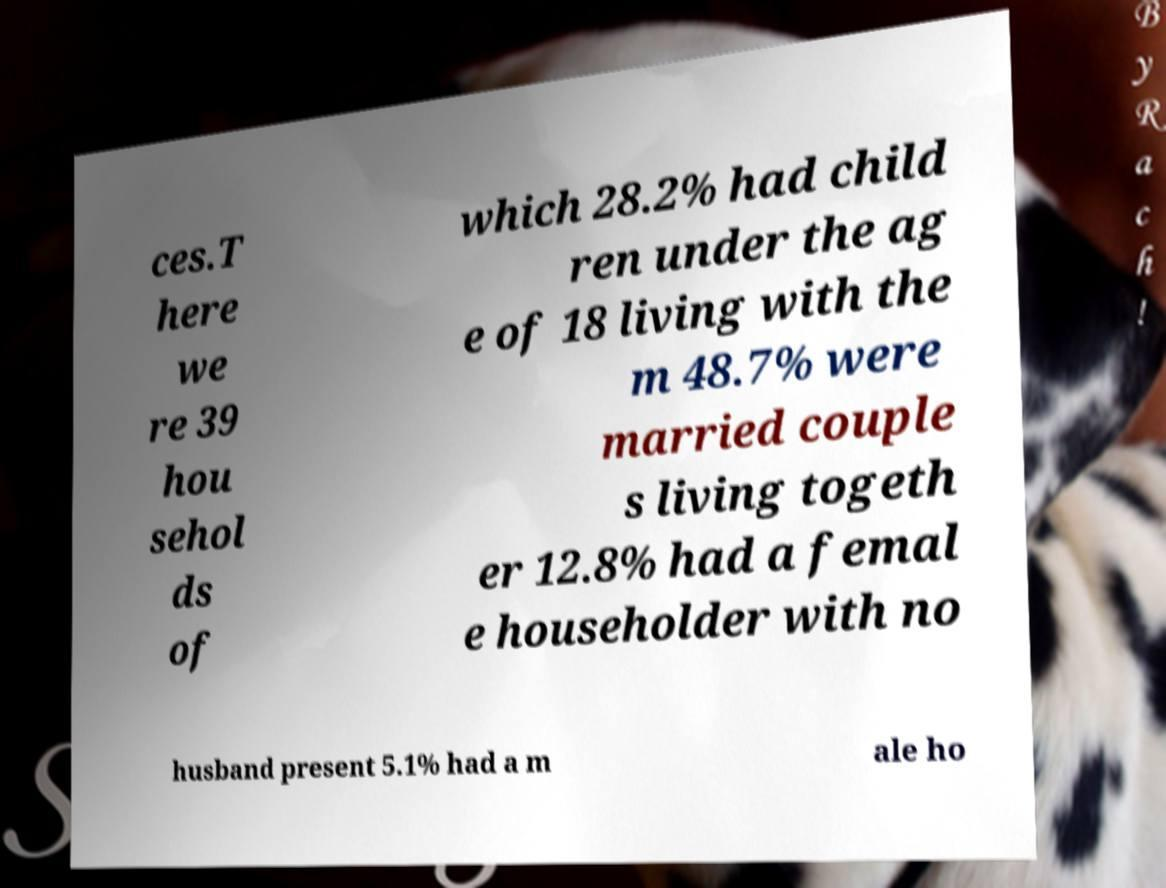Could you extract and type out the text from this image? ces.T here we re 39 hou sehol ds of which 28.2% had child ren under the ag e of 18 living with the m 48.7% were married couple s living togeth er 12.8% had a femal e householder with no husband present 5.1% had a m ale ho 